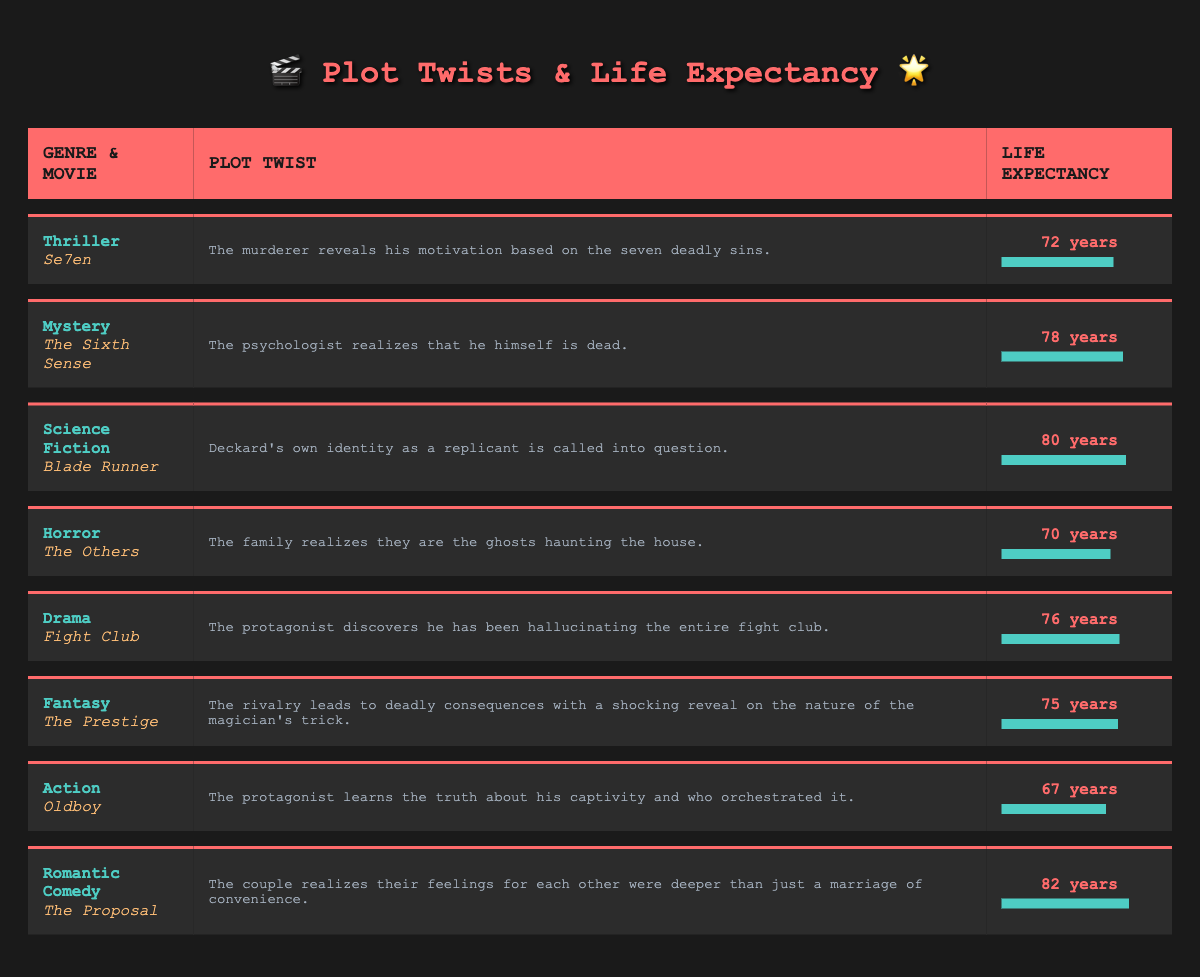What is the average life expectancy for the movie genre Thriller? The life expectancy for the movie "Se7en" in the Thriller genre is 72 years, which is the only data point in this genre provided in the table. Therefore, the average is also 72 years.
Answer: 72 years Which movie has the highest average life expectancy? Reviewing the life expectancy figures listed in the table, "The Proposal" in the Romantic Comedy genre has the highest average life expectancy at 82 years.
Answer: 82 years Is the average life expectancy for Horror greater than 70 years? The average life expectancy for the Horror genre, represented by "The Others," is 70 years. Since 70 is not greater than 70, the answer is no.
Answer: No What is the average life expectancy of the listed Science Fiction and Action movies? The average life expectancy for "Blade Runner" (Science Fiction) is 80 years, and for "Oldboy" (Action) it is 67 years. To find the average, add 80 and 67 to get 147, then divide by 2, resulting in 73.5.
Answer: 73.5 years Which genre has a plot twist related to a character realizing they are dead? The plot twist that involves a character realizing they are dead is found in "The Sixth Sense," which falls under the Mystery genre.
Answer: Mystery What is the difference in average life expectancy between the genres Drama and Fantasy? The average life expectancy for "Fight Club" in Drama is 76 years, while for "The Prestige" in Fantasy it is 75 years. The difference is calculated as 76 - 75, which equals 1 year.
Answer: 1 year How many movie genres listed have an average life expectancy below 75 years? From the table, two genres have an average life expectancy below 75 years: Horror (70 years) and Action (67 years), making a total count of 2 genres.
Answer: 2 genres Does the average life expectancy for Mystery movies exceed that of Horror movies? The average life expectancy for "The Sixth Sense" in Mystery is 78 years, while for "The Others" in Horror it is 70 years. Since 78 is greater than 70, the answer is yes.
Answer: Yes 